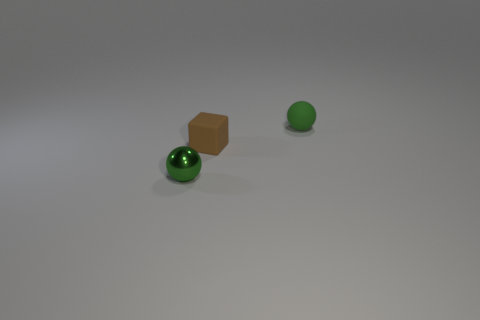Add 3 tiny spheres. How many objects exist? 6 Subtract all balls. How many objects are left? 1 Subtract all red cylinders. How many purple blocks are left? 0 Subtract 0 blue balls. How many objects are left? 3 Subtract 1 cubes. How many cubes are left? 0 Subtract all blue spheres. Subtract all purple cylinders. How many spheres are left? 2 Subtract all small brown cubes. Subtract all gray shiny cylinders. How many objects are left? 2 Add 1 tiny green matte things. How many tiny green matte things are left? 2 Add 1 brown rubber cubes. How many brown rubber cubes exist? 2 